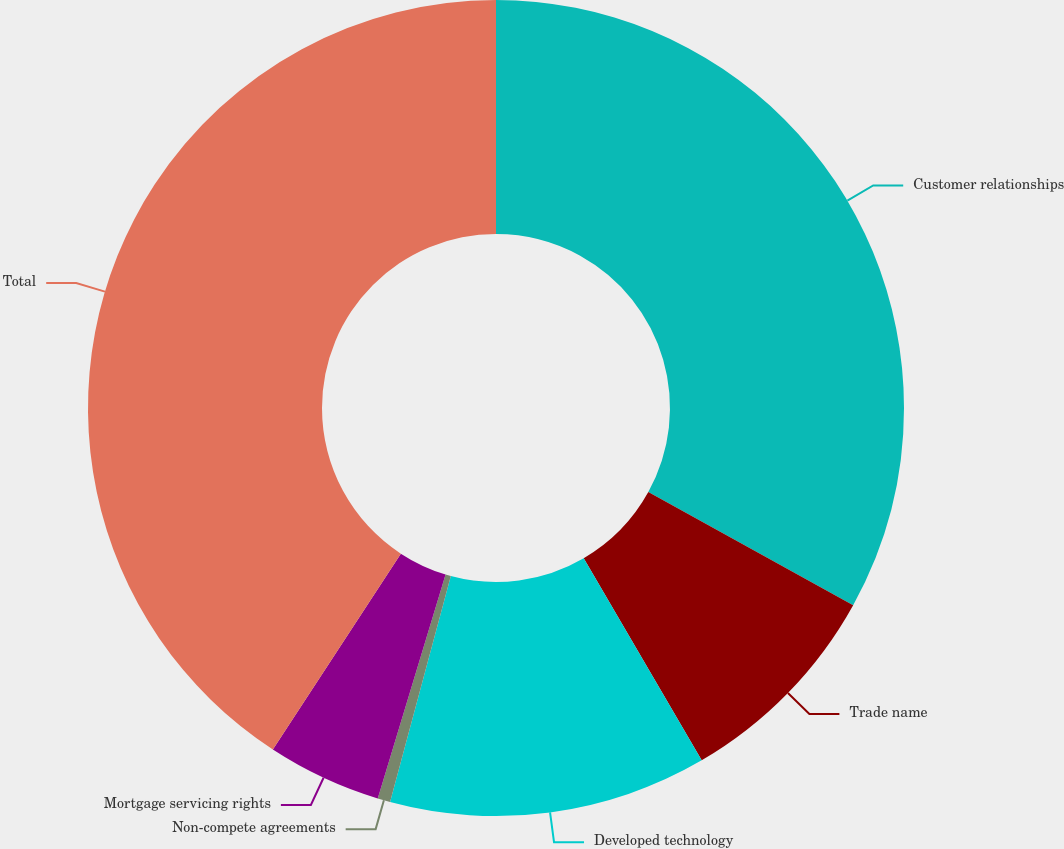Convert chart to OTSL. <chart><loc_0><loc_0><loc_500><loc_500><pie_chart><fcel>Customer relationships<fcel>Trade name<fcel>Developed technology<fcel>Non-compete agreements<fcel>Mortgage servicing rights<fcel>Total<nl><fcel>33.03%<fcel>8.56%<fcel>12.59%<fcel>0.5%<fcel>4.53%<fcel>40.79%<nl></chart> 